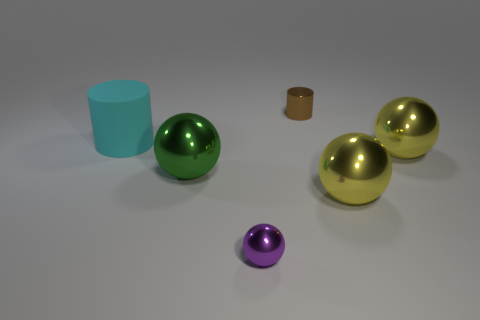Are there more tiny cylinders behind the tiny brown object than red rubber things? no 